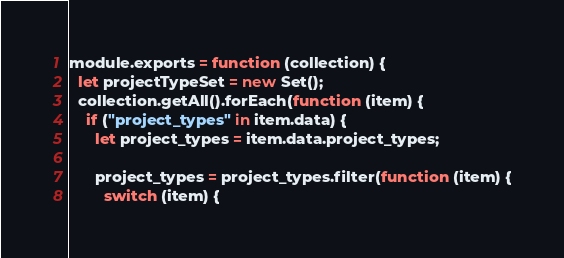<code> <loc_0><loc_0><loc_500><loc_500><_JavaScript_>module.exports = function (collection) {
  let projectTypeSet = new Set();
  collection.getAll().forEach(function (item) {
    if ("project_types" in item.data) {
      let project_types = item.data.project_types;

      project_types = project_types.filter(function (item) {
        switch (item) {</code> 